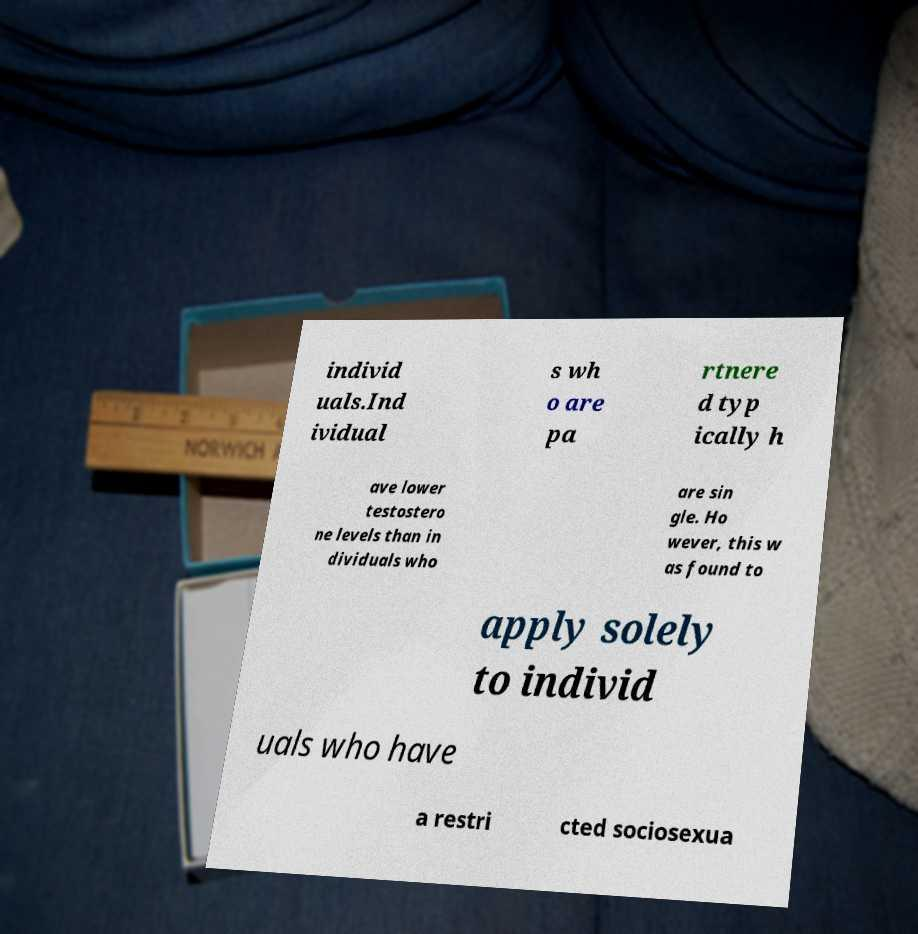Can you read and provide the text displayed in the image?This photo seems to have some interesting text. Can you extract and type it out for me? individ uals.Ind ividual s wh o are pa rtnere d typ ically h ave lower testostero ne levels than in dividuals who are sin gle. Ho wever, this w as found to apply solely to individ uals who have a restri cted sociosexua 